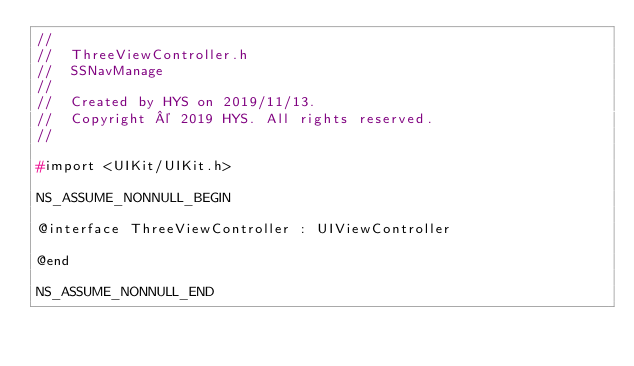<code> <loc_0><loc_0><loc_500><loc_500><_C_>//
//  ThreeViewController.h
//  SSNavManage
//
//  Created by HYS on 2019/11/13.
//  Copyright © 2019 HYS. All rights reserved.
//

#import <UIKit/UIKit.h>

NS_ASSUME_NONNULL_BEGIN

@interface ThreeViewController : UIViewController

@end

NS_ASSUME_NONNULL_END
</code> 